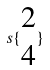<formula> <loc_0><loc_0><loc_500><loc_500>s \{ \begin{matrix} 2 \\ 4 \end{matrix} \}</formula> 